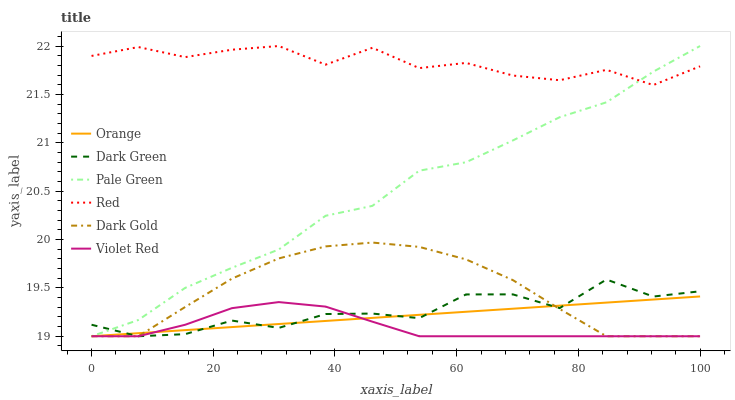Does Violet Red have the minimum area under the curve?
Answer yes or no. Yes. Does Red have the maximum area under the curve?
Answer yes or no. Yes. Does Dark Gold have the minimum area under the curve?
Answer yes or no. No. Does Dark Gold have the maximum area under the curve?
Answer yes or no. No. Is Orange the smoothest?
Answer yes or no. Yes. Is Dark Green the roughest?
Answer yes or no. Yes. Is Dark Gold the smoothest?
Answer yes or no. No. Is Dark Gold the roughest?
Answer yes or no. No. Does Red have the lowest value?
Answer yes or no. No. Does Red have the highest value?
Answer yes or no. Yes. Does Dark Gold have the highest value?
Answer yes or no. No. Is Dark Green less than Red?
Answer yes or no. Yes. Is Red greater than Orange?
Answer yes or no. Yes. Does Dark Gold intersect Violet Red?
Answer yes or no. Yes. Is Dark Gold less than Violet Red?
Answer yes or no. No. Is Dark Gold greater than Violet Red?
Answer yes or no. No. Does Dark Green intersect Red?
Answer yes or no. No. 